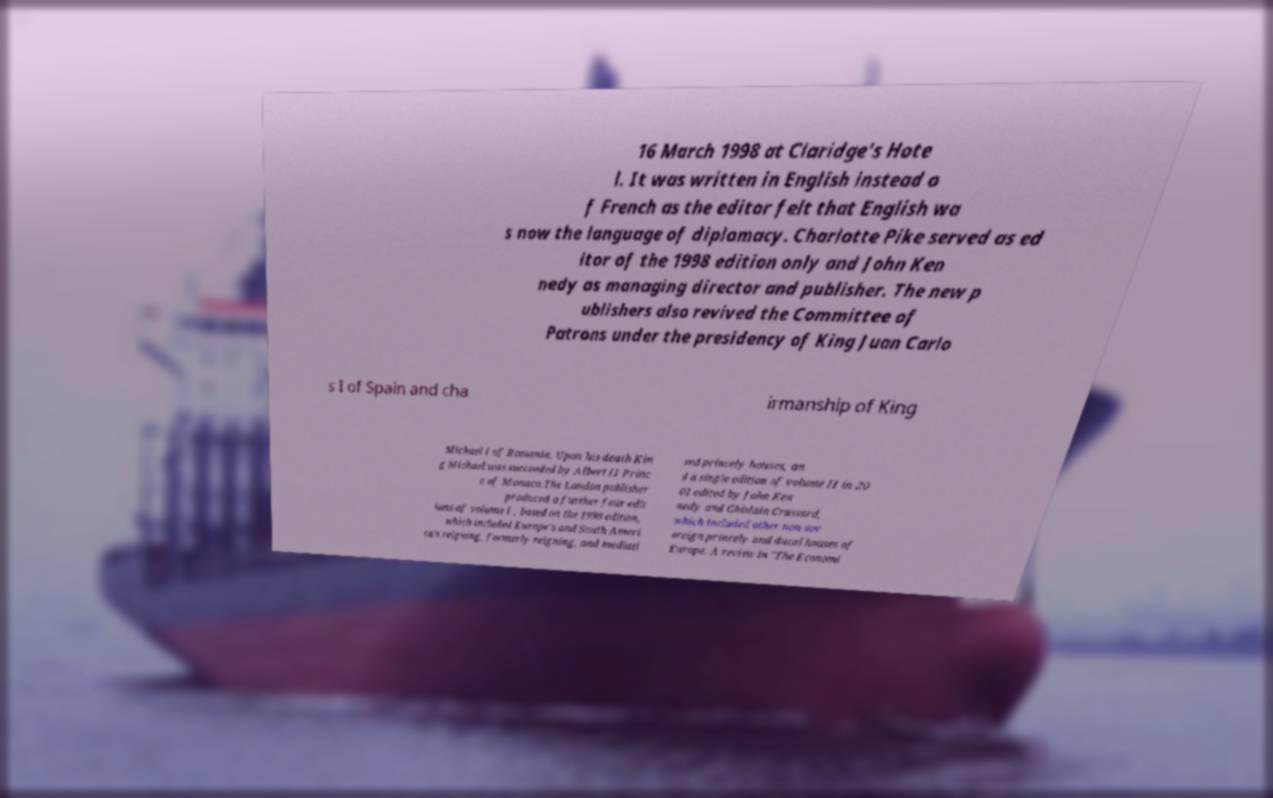Please read and relay the text visible in this image. What does it say? 16 March 1998 at Claridge's Hote l. It was written in English instead o f French as the editor felt that English wa s now the language of diplomacy. Charlotte Pike served as ed itor of the 1998 edition only and John Ken nedy as managing director and publisher. The new p ublishers also revived the Committee of Patrons under the presidency of King Juan Carlo s I of Spain and cha irmanship of King Michael I of Romania. Upon his death Kin g Michael was succeeded by Albert II Princ e of Monaco.The London publisher produced a further four edit ions of volume I , based on the 1998 edition, which included Europe's and South Ameri ca's reigning, formerly reigning, and mediati sed princely houses, an d a single edition of volume II in 20 01 edited by John Ken nedy and Ghislain Crassard, which included other non-sov ereign princely and ducal houses of Europe. A review in "The Economi 